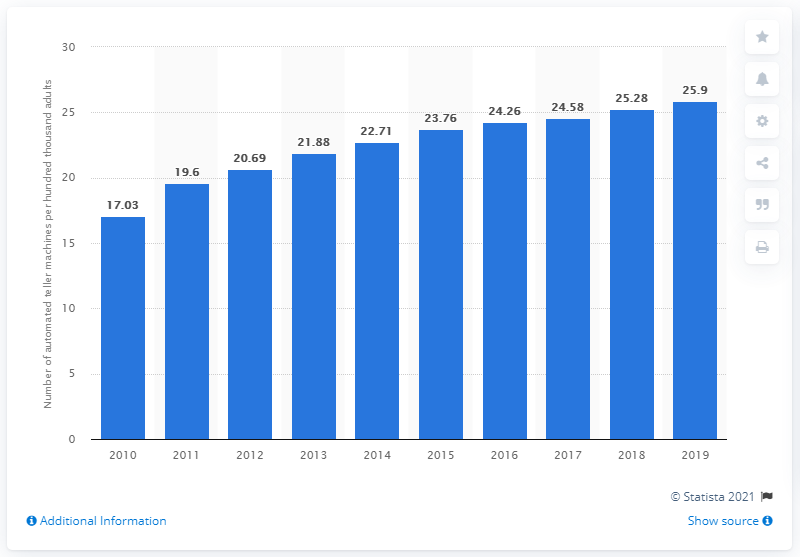Identify some key points in this picture. The number of ATMs per hundred thousand adults increased in 2010. In 2019, there were approximately 25.9 ATMs per 100 thousand adults in Vietnam. 